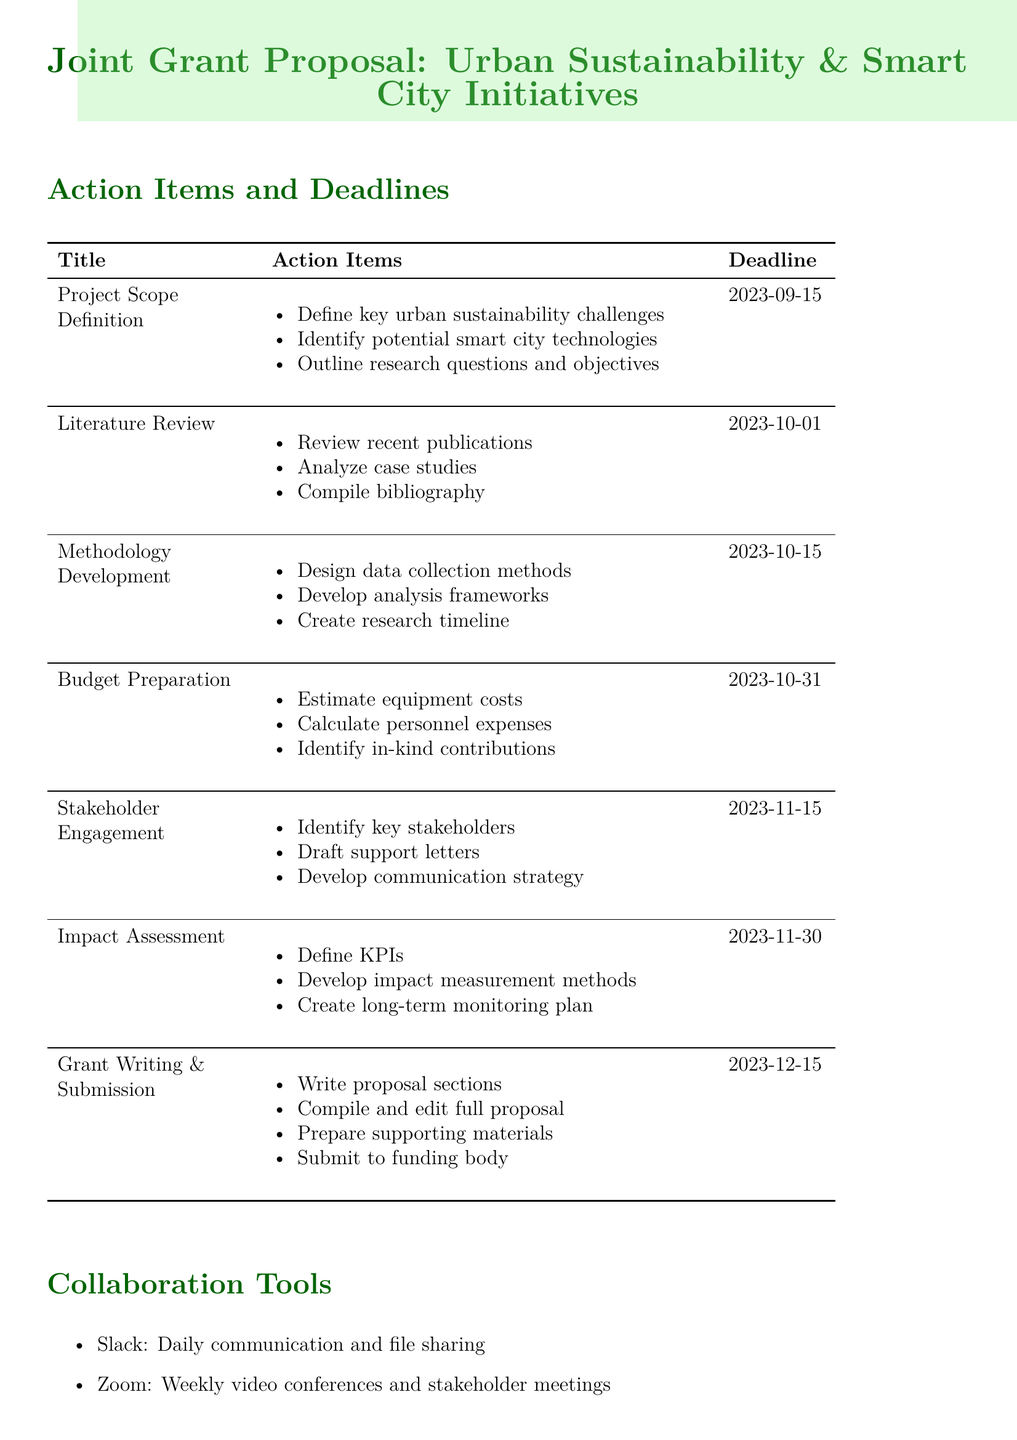What is the deadline for Project Scope Definition? The deadline for Project Scope Definition is specified in the document as 2023-09-15.
Answer: 2023-09-15 Who is responsible for the Budget Preparation? The document mentions that the Partner University is the lead and Your University is the support for Budget Preparation.
Answer: Lead: Partner University What action item is included under Stakeholder Engagement Plan? The action items listed for Stakeholder Engagement include identifying key stakeholders and drafting letters of support.
Answer: Identify key stakeholders What are the collaboration tools mentioned in the document? The document lists multiple collaboration tools including Slack, Zoom, Google Drive, and Trello.
Answer: Slack, Zoom, Google Drive, Trello How many action items are listed under Methodology Development? The document outlines three specific action items that fall under Methodology Development.
Answer: Three 